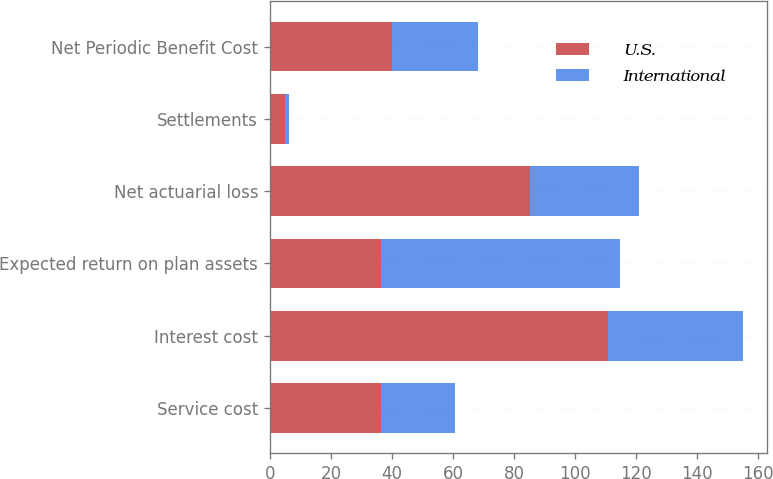<chart> <loc_0><loc_0><loc_500><loc_500><stacked_bar_chart><ecel><fcel>Service cost<fcel>Interest cost<fcel>Expected return on plan assets<fcel>Net actuarial loss<fcel>Settlements<fcel>Net Periodic Benefit Cost<nl><fcel>U.S.<fcel>36.5<fcel>110.7<fcel>36.5<fcel>85.3<fcel>5.1<fcel>40.1<nl><fcel>International<fcel>24.3<fcel>44.3<fcel>78.3<fcel>35.6<fcel>1.3<fcel>28<nl></chart> 